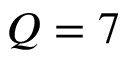Convert formula to latex. <formula><loc_0><loc_0><loc_500><loc_500>Q = 7</formula> 